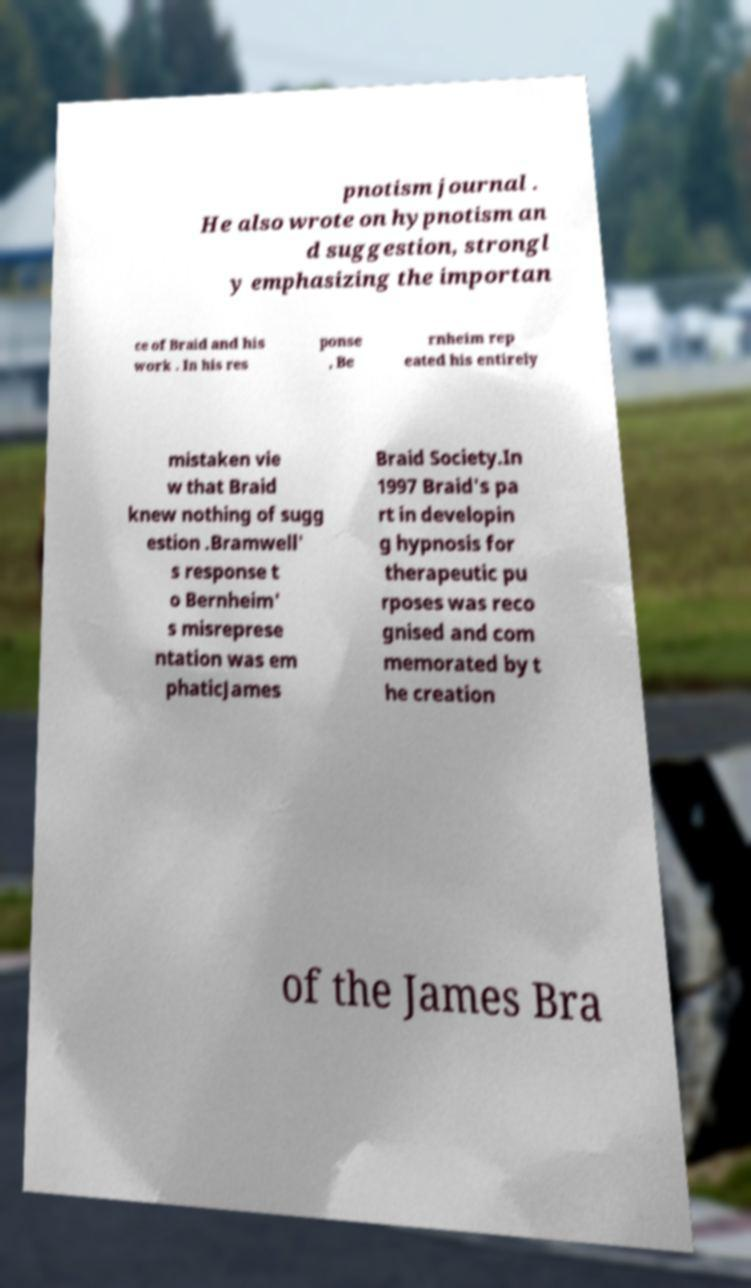Can you accurately transcribe the text from the provided image for me? pnotism journal . He also wrote on hypnotism an d suggestion, strongl y emphasizing the importan ce of Braid and his work . In his res ponse , Be rnheim rep eated his entirely mistaken vie w that Braid knew nothing of sugg estion .Bramwell' s response t o Bernheim' s misreprese ntation was em phaticJames Braid Society.In 1997 Braid's pa rt in developin g hypnosis for therapeutic pu rposes was reco gnised and com memorated by t he creation of the James Bra 